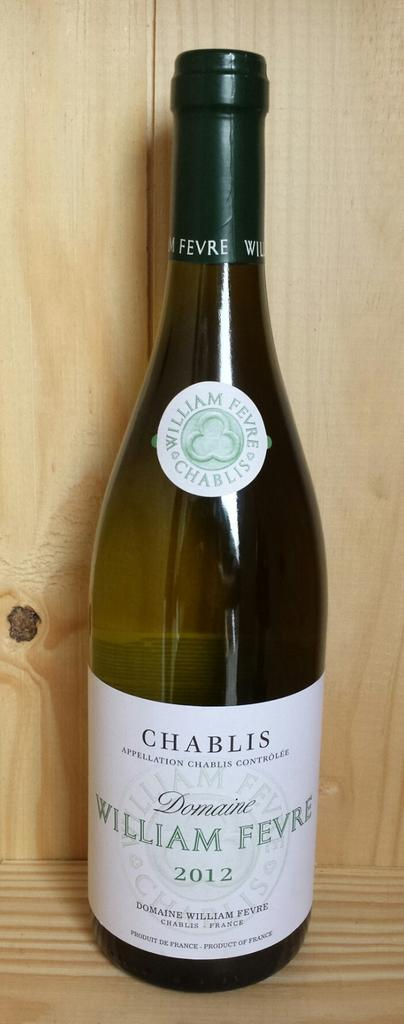<image>
Provide a brief description of the given image. A bottle with a white label with the name chablis on the top of the label. 